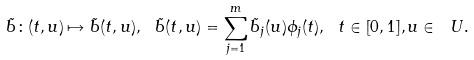<formula> <loc_0><loc_0><loc_500><loc_500>\tilde { b } \colon ( t , u ) \mapsto \tilde { b } ( t , u ) , \ \tilde { b } ( t , u ) = \sum _ { j = 1 } ^ { m } \tilde { b } _ { j } ( u ) \phi _ { j } ( t ) , \ t \in [ 0 , 1 ] , u \in \ U .</formula> 